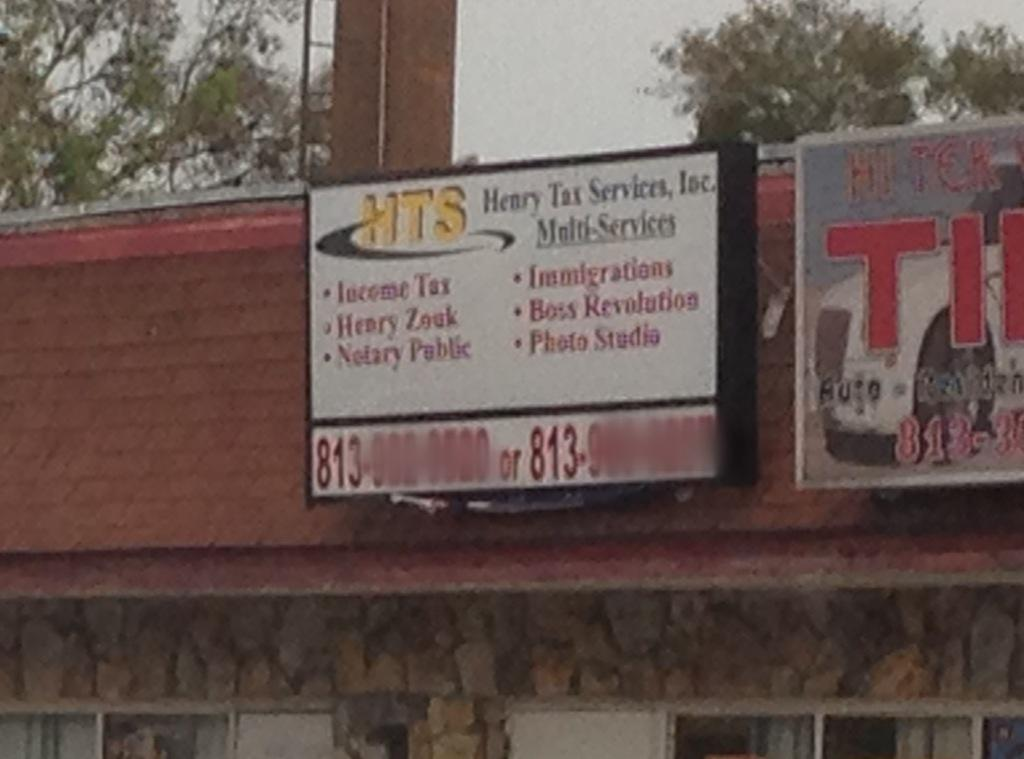<image>
Render a clear and concise summary of the photo. A Henry Tax Service Inc billboard on a an angled shop roof advertises multiple services. 